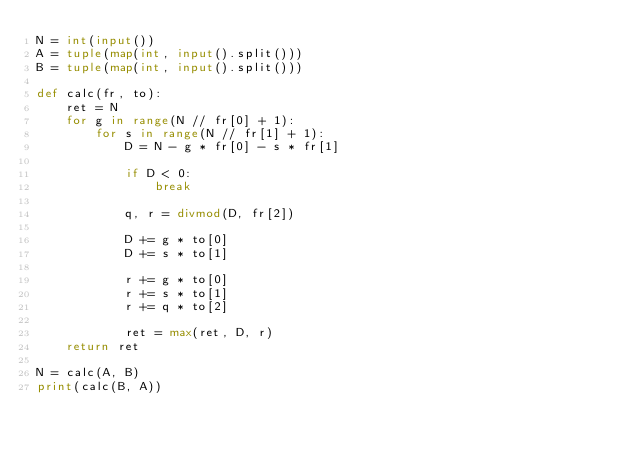<code> <loc_0><loc_0><loc_500><loc_500><_Python_>N = int(input())
A = tuple(map(int, input().split()))
B = tuple(map(int, input().split()))

def calc(fr, to):
    ret = N
    for g in range(N // fr[0] + 1):
        for s in range(N // fr[1] + 1):
            D = N - g * fr[0] - s * fr[1]

            if D < 0:
                break

            q, r = divmod(D, fr[2])

            D += g * to[0]
            D += s * to[1]

            r += g * to[0]
            r += s * to[1]
            r += q * to[2]

            ret = max(ret, D, r)
    return ret

N = calc(A, B)
print(calc(B, A))
</code> 